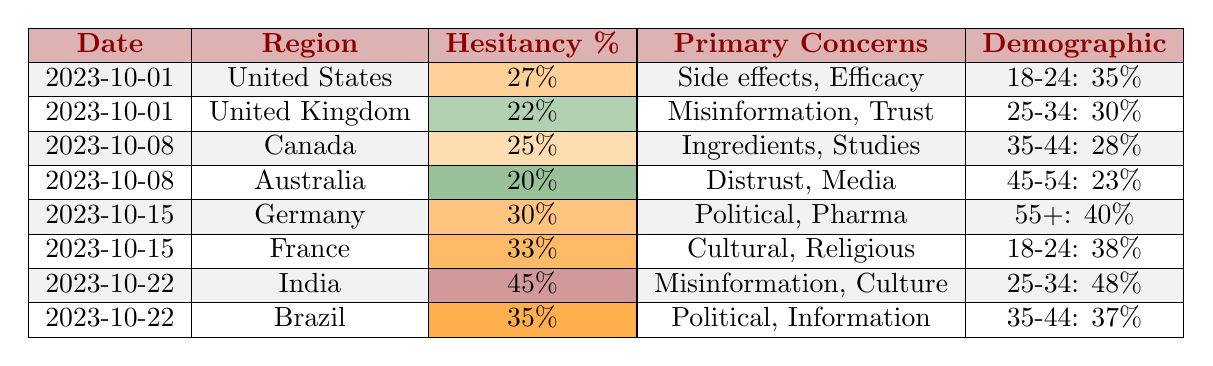What percentage of vaccine hesitancy was recorded in India on October 22, 2023? The table states that on October 22, 2023, the region of India had a recorded vaccine hesitancy of 45%.
Answer: 45% Which country had the highest vaccine hesitancy percentage in the table? Upon examining the table, India has the highest hesitancy percentage at 45%.
Answer: India What is the age group most hesitant to get vaccinated in the United States? The table shows that the age group 18-24 in the United States has a hesitancy percentage of 35%, which is the highest among other age groups listed in that region.
Answer: 18-24 Which primary concern was shared by those hesitant in both Germany and France? By reviewing the primary concerns listed in the table, both Germany and France have concerns related to politics (Germany: Political influence, France: Cultural views which may imply political influences).
Answer: Political concerns What is the average percentage of vaccine hesitancy across all countries listed for the date October 8, 2023? The hesitancy percentages for October 8, 2023, are Canada (25%) and Australia (20%). Adding these gives 45%, and then dividing by 2 (the number of regions) gives an average of 22.5%.
Answer: 22.5% Did any region report over 30% hesitancy on October 15, 2023? On October 15, 2023, both Germany (30%) and France (33%) reported hesitancy percentages equal to or greater than 30%. Therefore, the answer is yes.
Answer: Yes How does the vaccine hesitancy of the demographic group aged 55+ in Germany compare to that of the 25-34 age group in India? In Germany, the hesitancy for the 55+ age group is 40%, while in India, the 25-34 age group has a hesitancy percentage of 48%. Since 48% is greater than 40%, India's hesitancy is higher.
Answer: India's hesitancy is higher Which country reported the lowest vaccine hesitancy percentage overall? The lowest percentage in the table is recorded for Australia with a hesitancy of 20%.
Answer: Australia What is the difference in vaccine hesitancy percentage between France and the United Kingdom? France has a hesitancy percentage of 33% and the United Kingdom has a hesitancy percentage of 22%. Subtracting these gives a difference of 11%.
Answer: 11% 